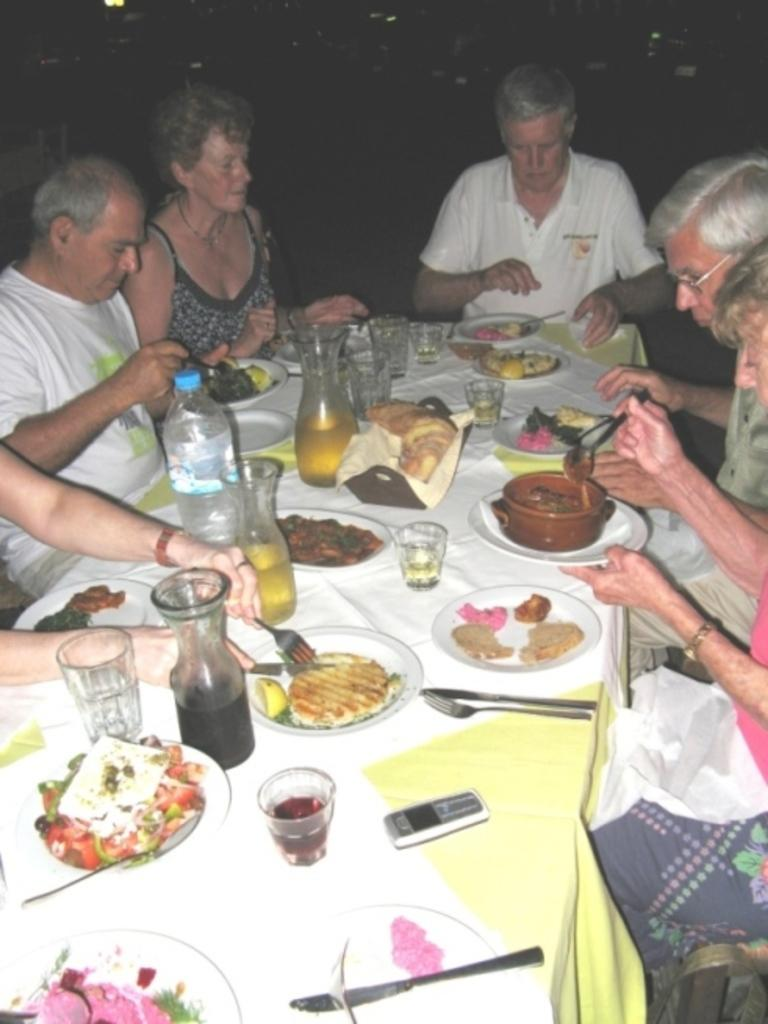Who is present in the image? There are people in the image. What are the people doing in the image? The people are sitting on chairs. Where are the chairs located in relation to the table? The chairs are near a table. What activity are the people engaged in while sitting on the chairs? The people are having food. What type of pollution can be seen in the image? There is no pollution present in the image. How many chickens are visible in the image? There are no chickens present in the image. 